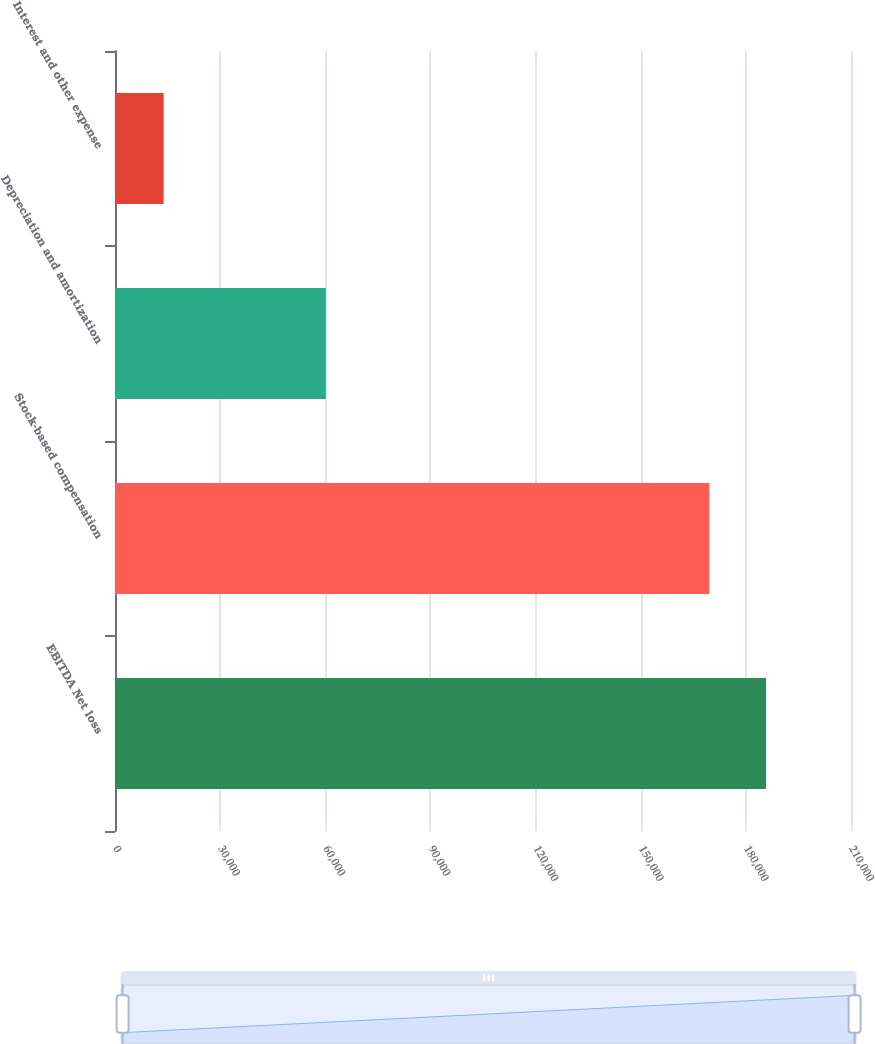<chart> <loc_0><loc_0><loc_500><loc_500><bar_chart><fcel>EBITDA Net loss<fcel>Stock-based compensation<fcel>Depreciation and amortization<fcel>Interest and other expense<nl><fcel>185761<fcel>169602<fcel>60155<fcel>13874<nl></chart> 